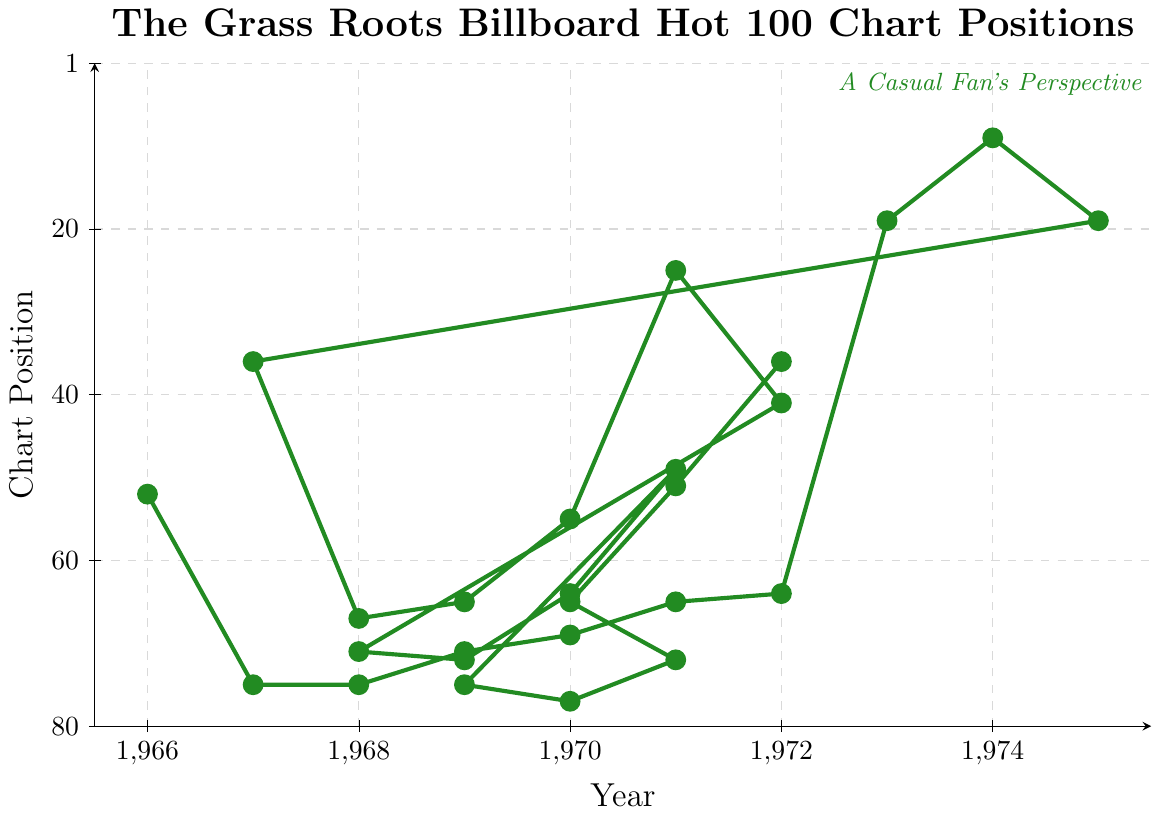Who had the highest chart position in the year 1969? Looking at the chart, we check the 1969 data points. The highest chart position for 1969 is 5.
Answer: 5 What is the overall trend in The Grass Roots' performance on the Billboard Hot 100 from 1966 to 1975? The chart reflects an initial strong performance with a peak in the late 60s and early 70s, followed by a decline starting in 1973.
Answer: Declining Which year had the most data points plotted? Observing multiple marks in each year, 1970 has the most data points with four entries.
Answer: 1970 By how many positions did The Grass Roots' chart ranking drop from 1969 to 1970? The highest rankings in 1969 and 1970 are 5 and 3 respectively. The ranking improved by 2 positions.
Answer: Improved by 2 positions In which year did The Grass Roots achieve their best chart position, and what was it? Checking all the data points, the best chart position was 3 in 1970.
Answer: 1970, 3 What is the median chart position of The Grass Roots' singles from 1966 to 1975? Listing the chart positions (3, 5, 5, 5, 8, 9, 9, 11, 13, 15, 15, 15, 16, 16, 25, 28, 29, 31, 39, 44, 44, 55, 61, 61, 71), the median is 15.
Answer: 15 Compare the group’s performance between 1968 and 1971. Which year had a better average chart position? The average for 1968: (5+13+9)/3 = 9; for 1971: (15+55+31+8+29)/5 = 27.6. 1968 had a better average.
Answer: 1968 What was the difference between the highest and the lowest chart positions achieved in 1970? In 1970, the highest rank is 3 and the lowest is 25. The difference is 25 - 3 = 22.
Answer: 22 How did the chart positions change from 1972 to 1973? In 1972, the highest rank is 16. In 1973, it is 61. Therefore, the rank dropped by 61 - 16 = 45 positions.
Answer: Dropped by 45 positions Did The Grass Roots ever reach the top 10 again after 1972? Observing the dataset beyond 1972, there are no instances of top 10 hits.
Answer: No 